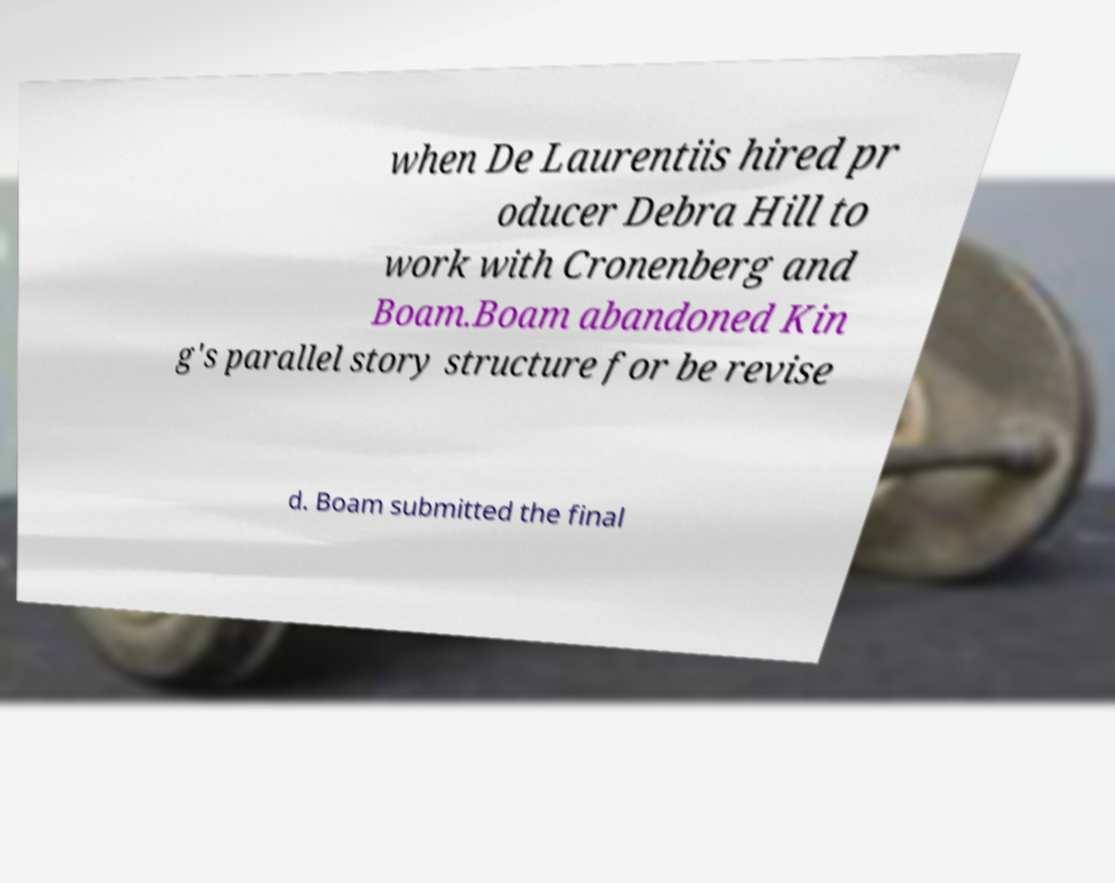What messages or text are displayed in this image? I need them in a readable, typed format. when De Laurentiis hired pr oducer Debra Hill to work with Cronenberg and Boam.Boam abandoned Kin g's parallel story structure for be revise d. Boam submitted the final 